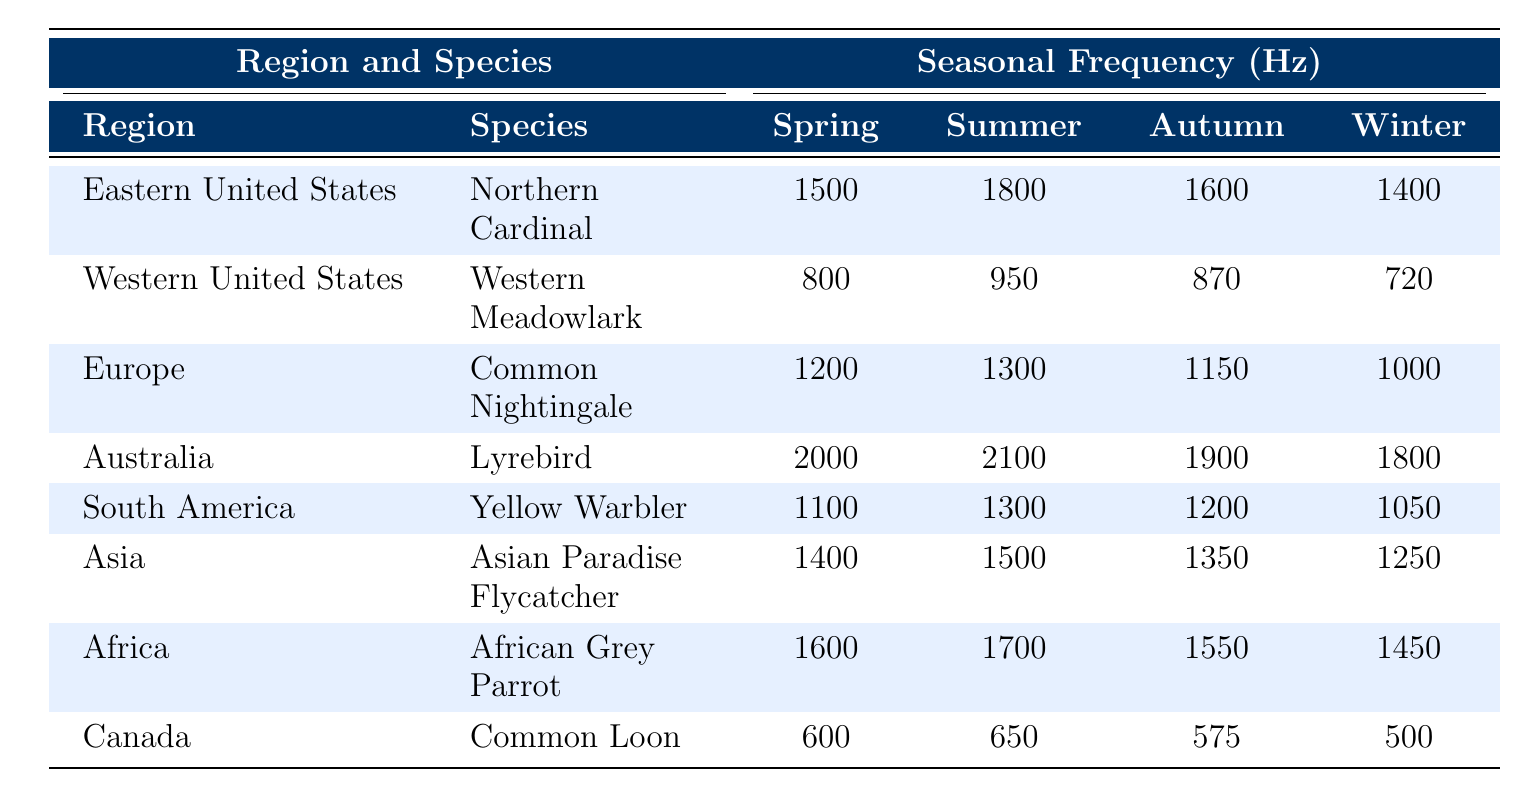What is the song frequency of the Northern Cardinal in summer? The table shows that the summer frequency for the Northern Cardinal, located in the Eastern United States, is 1800 Hz.
Answer: 1800 Hz Which region has the highest winter frequency among the species listed? The highest winter frequency can be found by comparing the values in the "WinterFrequency (Hz)" column. The Lyrebird from Australia has a winter frequency of 1800 Hz, which is higher than all others listed.
Answer: Australia (Lyrebird, 1800 Hz) What is the difference in spring frequencies between the Common Loon and the Western Meadowlark? The spring frequency for the Common Loon is 600 Hz, and for the Western Meadowlark, it is 800 Hz. The difference is calculated as 800 - 600 = 200 Hz.
Answer: 200 Hz Is the summer frequency of the African Grey Parrot greater than the autumn frequency of the Common Nightingale? The summer frequency of the African Grey Parrot is 1700 Hz, while the autumn frequency of the Common Nightingale is 1150 Hz. Since 1700 is greater than 1150, the statement is true.
Answer: Yes What is the average autumn frequency of the birds listed in the table? First, sum the autumn frequencies: 1600 (Northern Cardinal) + 870 (Western Meadowlark) + 1150 (Common Nightingale) + 1900 (Lyrebird) + 1200 (Yellow Warbler) + 1350 (Asian Paradise Flycatcher) + 1550 (African Grey Parrot) + 575 (Common Loon) = 10720 Hz. Then divide by the number of species (8) to find the average: 10720 / 8 = 1340 Hz.
Answer: 1340 Hz Which species shows the greatest increase in frequency from spring to summer? To find the greatest increase, calculate the difference between spring and summer frequencies for each species: Northern Cardinal (1800 - 1500 = 300), Western Meadowlark (950 - 800 = 150), Common Nightingale (1300 - 1200 = 100), Lyrebird (2100 - 2000 = 100), Yellow Warbler (1300 - 1100 = 200), Asian Paradise Flycatcher (1500 - 1400 = 100), African Grey Parrot (1700 - 1600 = 100), Common Loon (650 - 600 = 50). The Northern Cardinal has the highest increase of 300 Hz.
Answer: Northern Cardinal (300 Hz) What is the winter frequency of the Yellow Warbler compared to the summer frequency of the Common Loon? The Yellow Warbler's winter frequency is 1050 Hz, while the Common Loon's summer frequency is 650 Hz. Since 1050 is greater than 650, the Yellow Warbler has a higher winter frequency than the Common Loon's summer frequency.
Answer: Yes How do the autumn frequencies of the Lyrebird and the African Grey Parrot compare? The Lyrebird has an autumn frequency of 1900 Hz and the African Grey Parrot has an autumn frequency of 1550 Hz. Since 1900 is greater than 1550, the Lyrebird has a higher autumn frequency.
Answer: Lyrebird > African Grey Parrot 